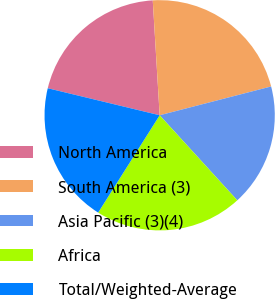Convert chart. <chart><loc_0><loc_0><loc_500><loc_500><pie_chart><fcel>North America<fcel>South America (3)<fcel>Asia Pacific (3)(4)<fcel>Africa<fcel>Total/Weighted-Average<nl><fcel>20.27%<fcel>21.93%<fcel>17.25%<fcel>20.74%<fcel>19.8%<nl></chart> 